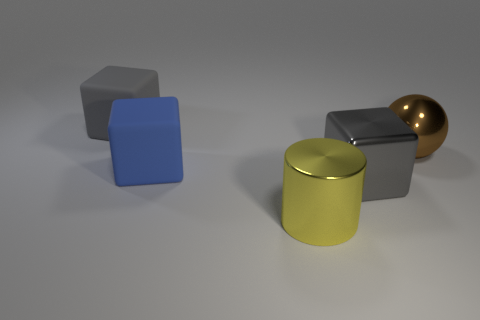Are there any other things that have the same material as the big cylinder? Yes, the sphere on the right appears to have a similarly reflective and smooth surface, suggesting it may be made of a material akin to the big cylinder, possibly a polished metal or plastic. 